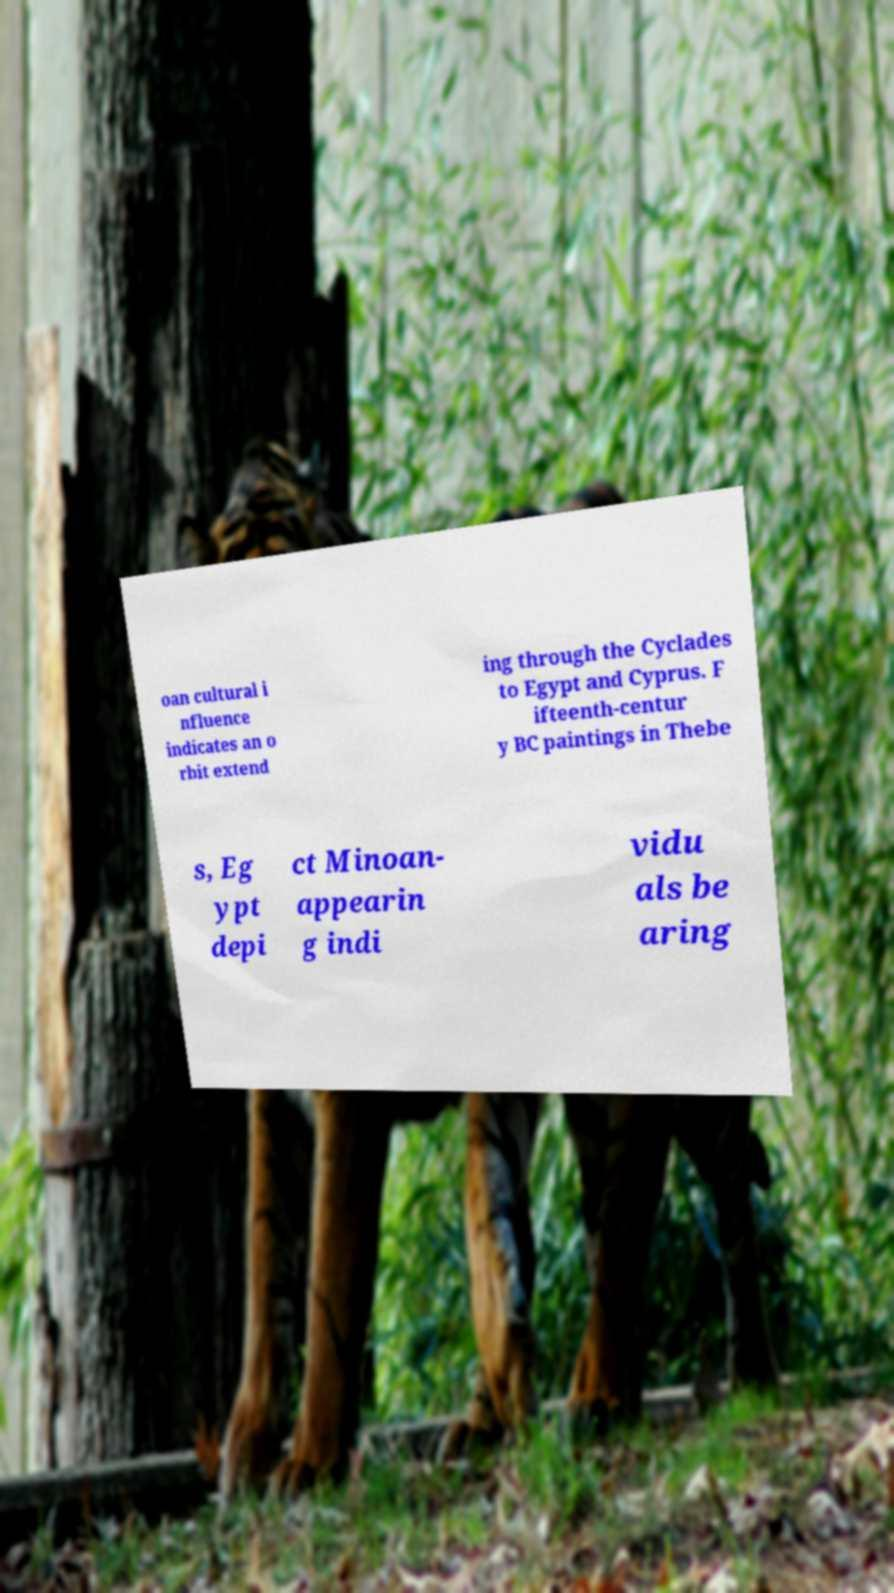Please read and relay the text visible in this image. What does it say? oan cultural i nfluence indicates an o rbit extend ing through the Cyclades to Egypt and Cyprus. F ifteenth-centur y BC paintings in Thebe s, Eg ypt depi ct Minoan- appearin g indi vidu als be aring 